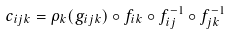<formula> <loc_0><loc_0><loc_500><loc_500>c _ { i j k } = \rho _ { k } ( g _ { i j k } ) \circ f _ { i k } \circ f _ { i j } ^ { - 1 } \circ f _ { j k } ^ { - 1 }</formula> 